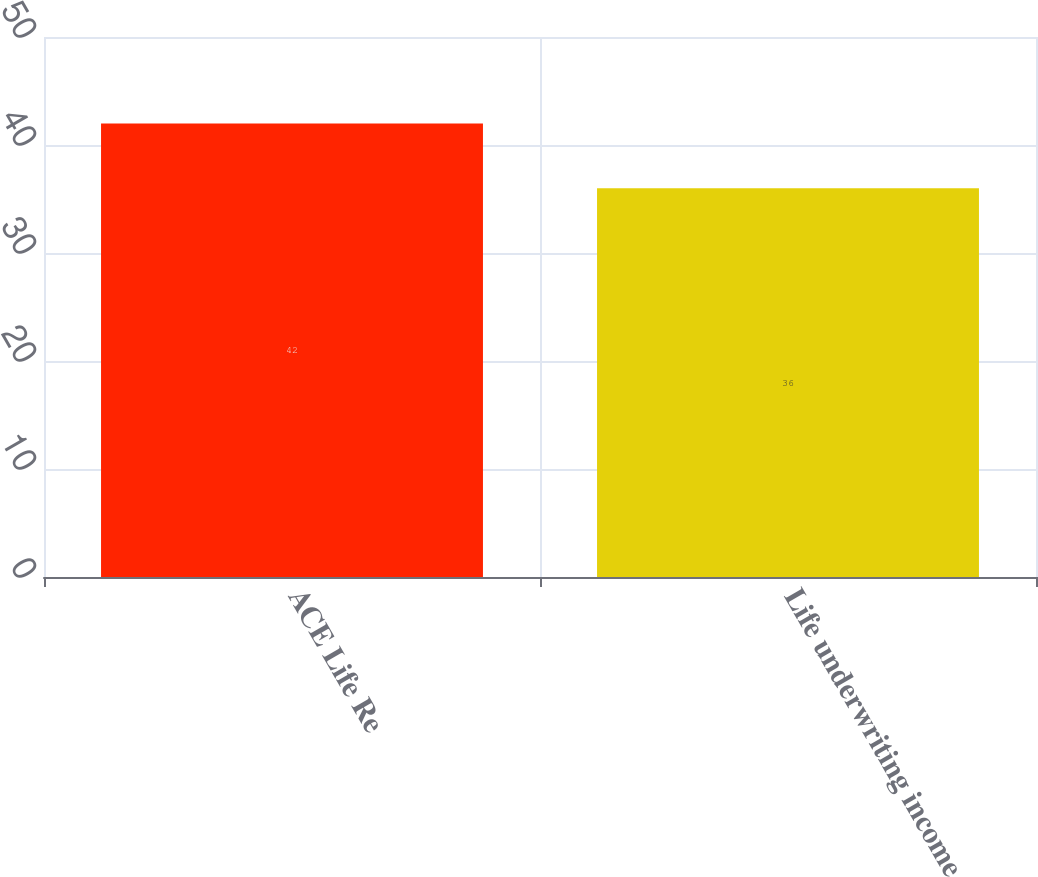Convert chart. <chart><loc_0><loc_0><loc_500><loc_500><bar_chart><fcel>ACE Life Re<fcel>Life underwriting income<nl><fcel>42<fcel>36<nl></chart> 